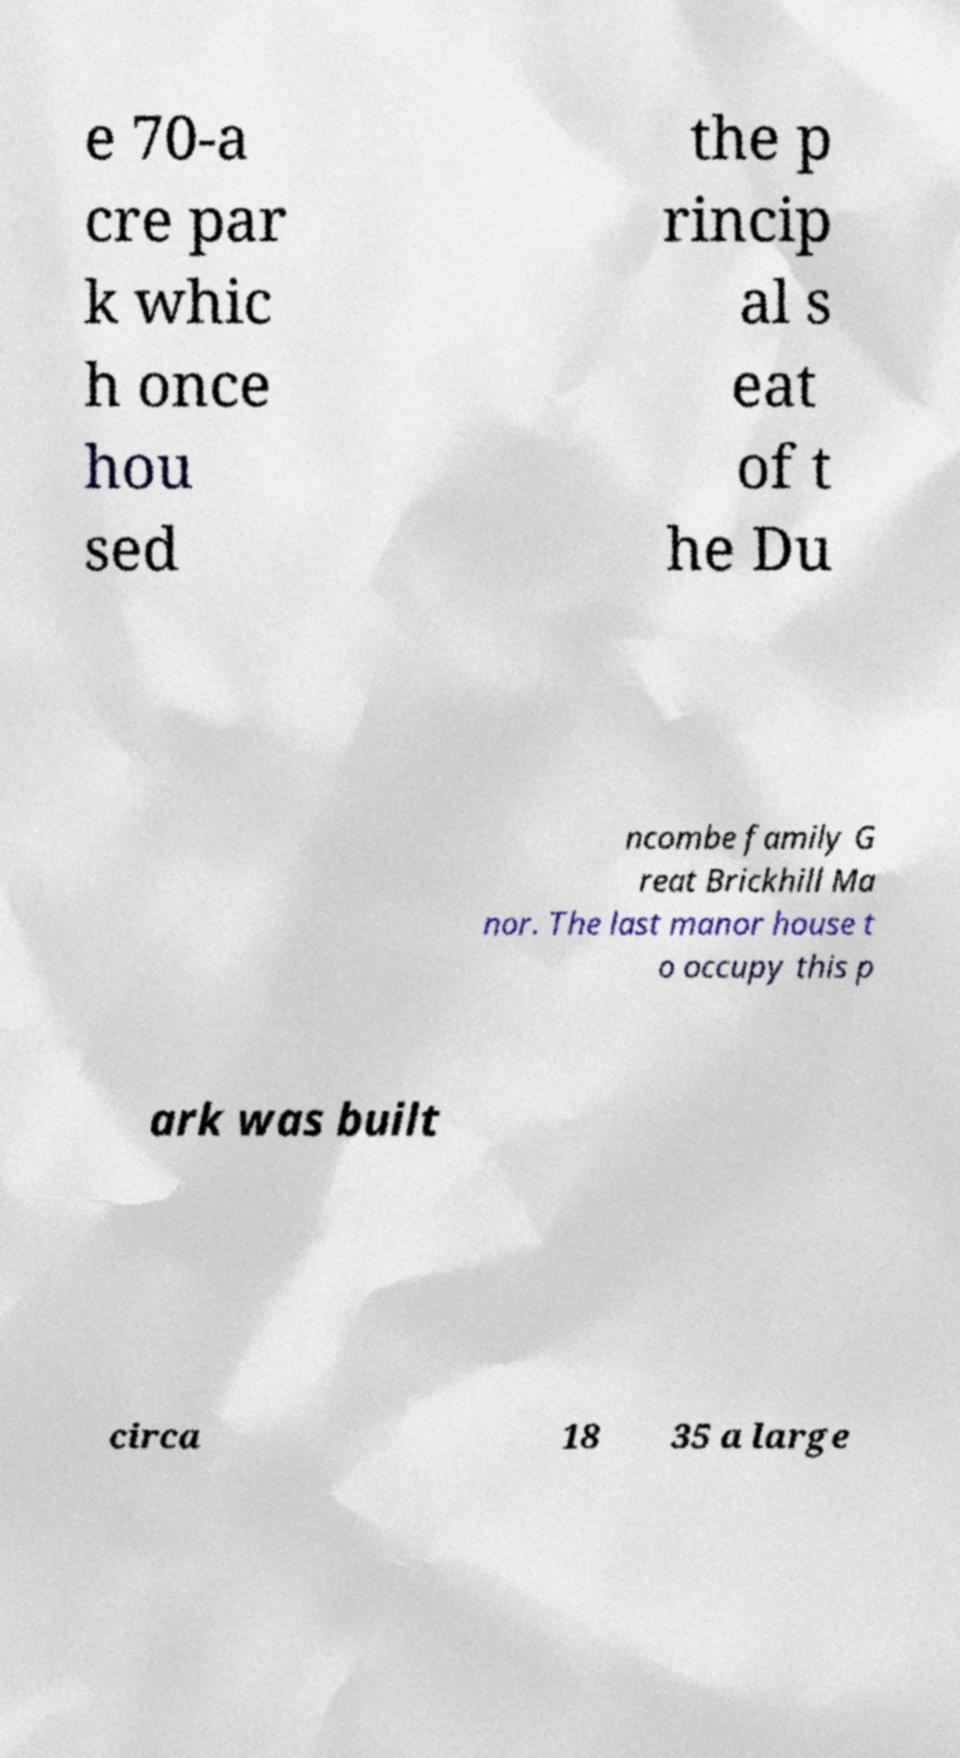Please identify and transcribe the text found in this image. e 70-a cre par k whic h once hou sed the p rincip al s eat of t he Du ncombe family G reat Brickhill Ma nor. The last manor house t o occupy this p ark was built circa 18 35 a large 